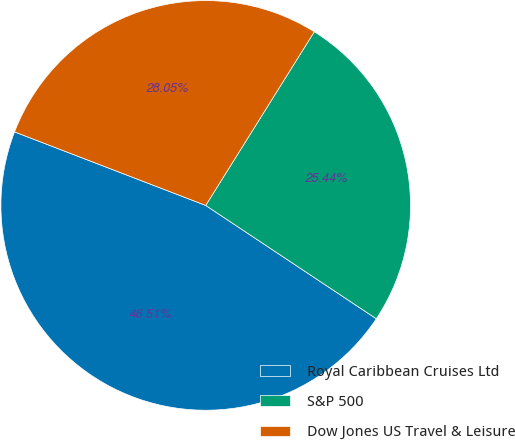Convert chart. <chart><loc_0><loc_0><loc_500><loc_500><pie_chart><fcel>Royal Caribbean Cruises Ltd<fcel>S&P 500<fcel>Dow Jones US Travel & Leisure<nl><fcel>46.51%<fcel>25.44%<fcel>28.05%<nl></chart> 